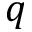<formula> <loc_0><loc_0><loc_500><loc_500>q</formula> 